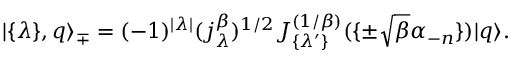Convert formula to latex. <formula><loc_0><loc_0><loc_500><loc_500>| \{ \lambda \} , q \rangle _ { \mp } = ( - 1 ) ^ { | \lambda | } ( j _ { \lambda } ^ { \beta } ) ^ { 1 / 2 } J _ { \{ \lambda ^ { \prime } \} } ^ { ( 1 / \beta ) } ( \{ \pm \sqrt { \beta } \alpha _ { - n } \} ) | q \rangle .</formula> 